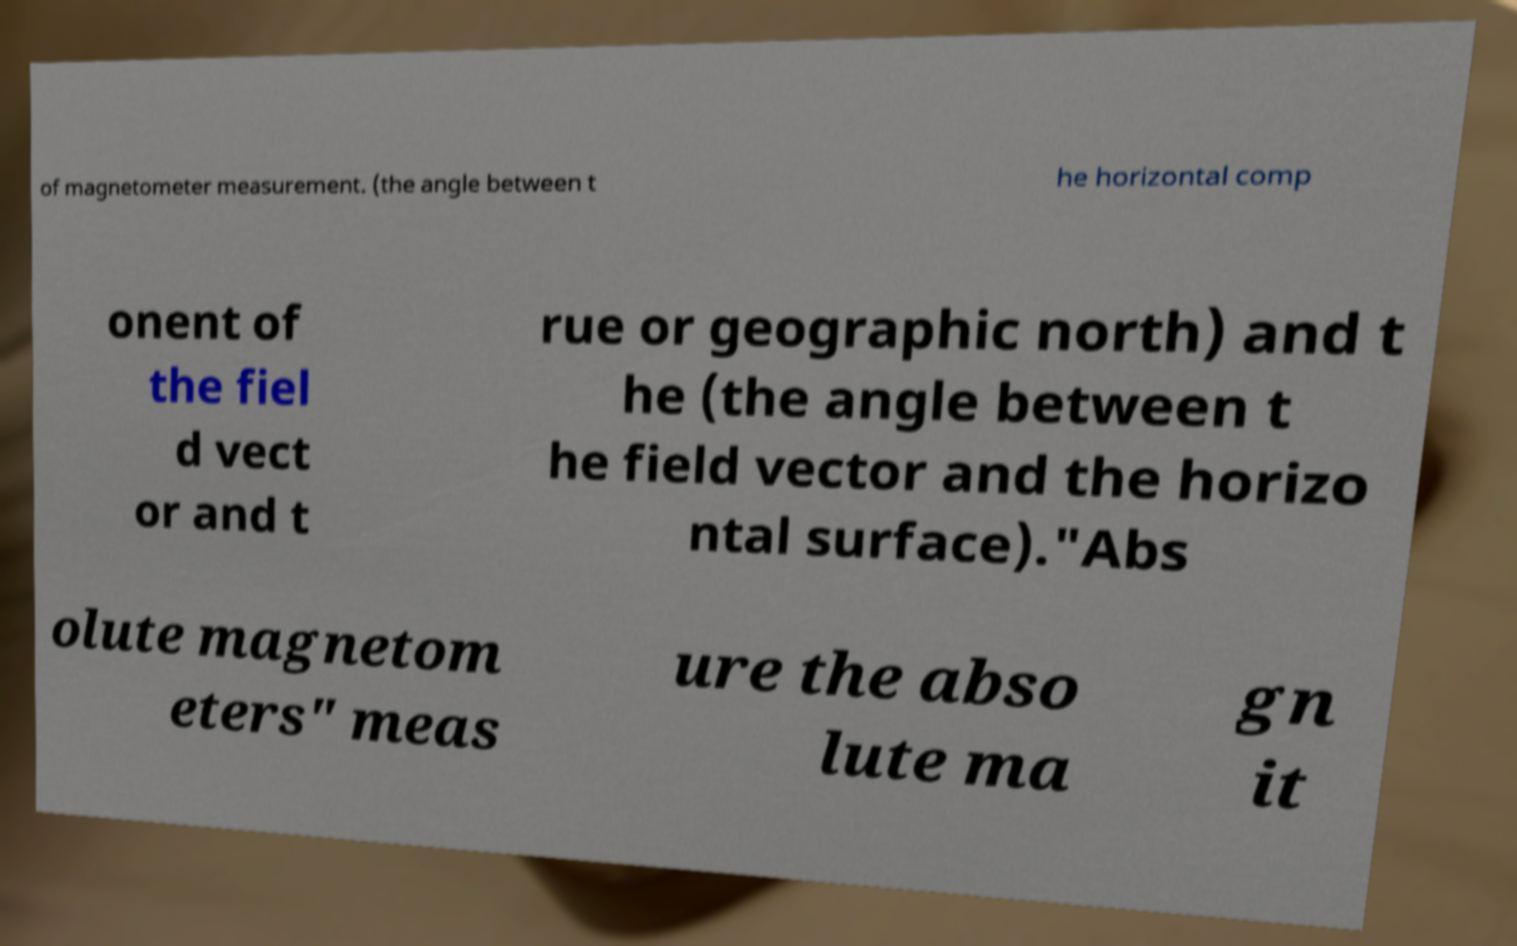Could you assist in decoding the text presented in this image and type it out clearly? of magnetometer measurement. (the angle between t he horizontal comp onent of the fiel d vect or and t rue or geographic north) and t he (the angle between t he field vector and the horizo ntal surface)."Abs olute magnetom eters" meas ure the abso lute ma gn it 